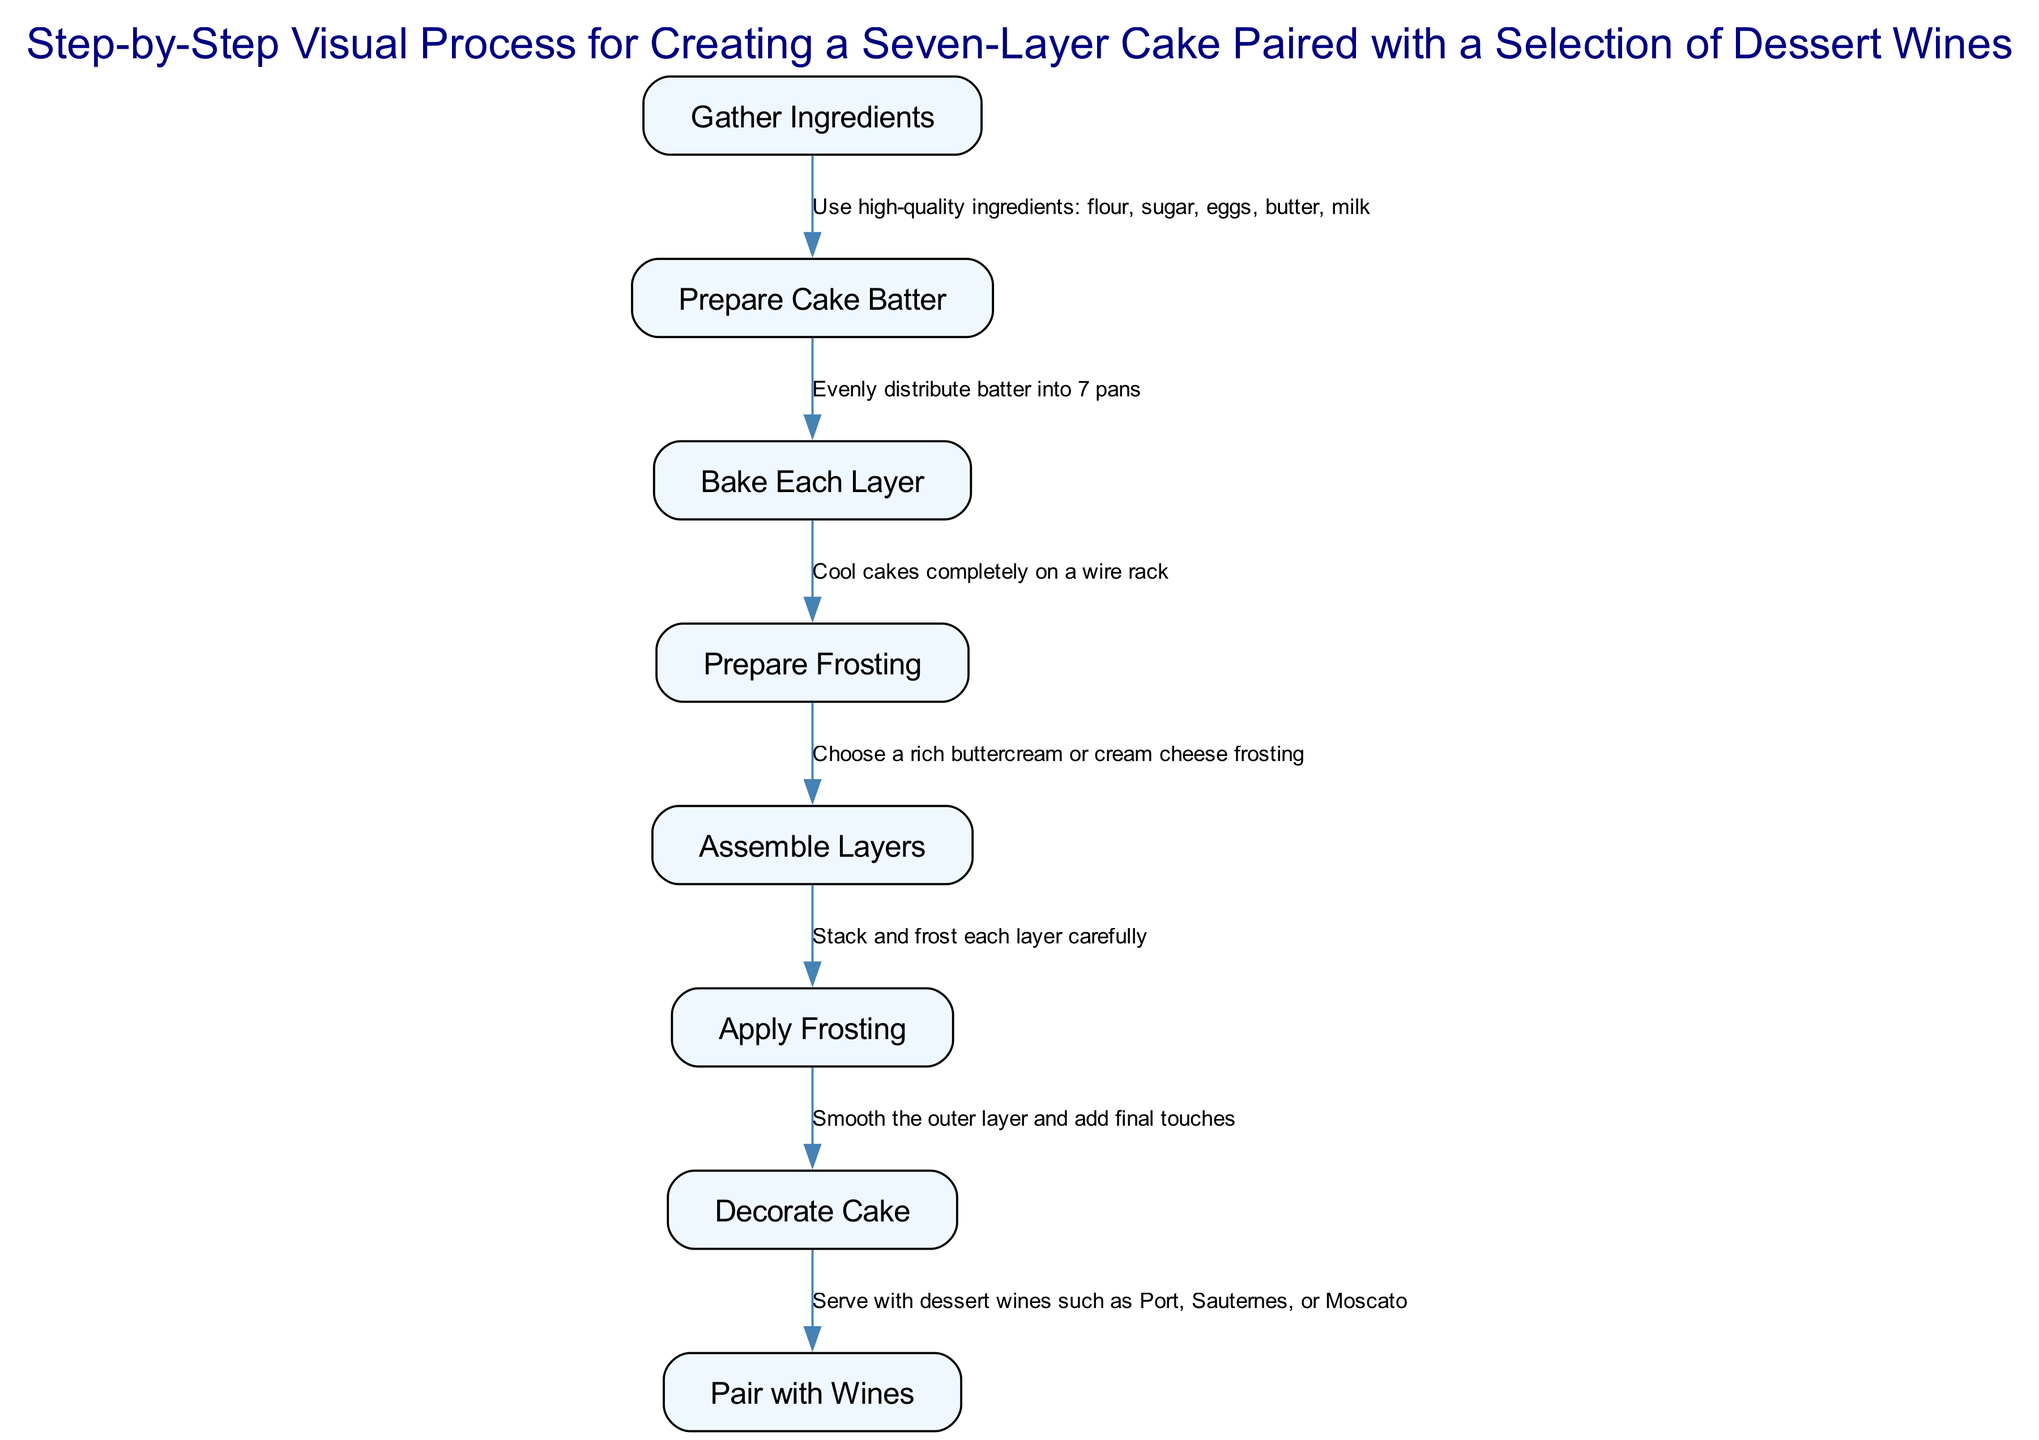What is the first step in the process? The diagram starts with the node labeled "Gather Ingredients," indicating that this is the initial action to be taken in creating the cake.
Answer: Gather Ingredients How many layers does the cake have? The diagram indicates that the cake is a seven-layer cake, as mentioned in the title and throughout the process of preparation.
Answer: Seven What comes after preparing the frosting? Following the preparation of frosting, the next step in the diagram is to "Assemble Layers," which involves stacking the cake layers.
Answer: Assemble Layers Which frosting options are suggested in the process? The diagram states that you should choose either a rich buttercream or cream cheese frosting after preparing the frosting.
Answer: Buttercream or cream cheese What dessert wines are recommended to pair with the cake? The final step of the process specifies dessert wines such as Port, Sauternes, or Moscato for pairing with the cake.
Answer: Port, Sauternes, or Moscato What steps are directly related to frosting? The diagram outlines a sequence where "Prepare Frosting" leads to "Assemble Layers," which then connects to "Apply Frosting" and "Decorate Cake." This indicates that frosting is crucial in the layering and finishing stages. Therefore, the steps directly related to frosting would be preparing, applying, and decorating.
Answer: Prepare Frosting, Apply Frosting, Decorate Cake What is the relationship between baking each layer and frosting options? The step of "Bake Each Layer" is a prerequisite that must be completed before "Prepare Frosting," indicating that you must bake the layers before you can decide on the frosting options for the cake. The preparation and application of frosting can only occur after the layers are baked and cooled.
Answer: You must bake the layers first How many edges or connections are in the flow? There are a total of 7 edges connecting the steps in the process. Each edge represents the flow from one step to the next, indicating the sequence of actions required to create the cake.
Answer: Seven 